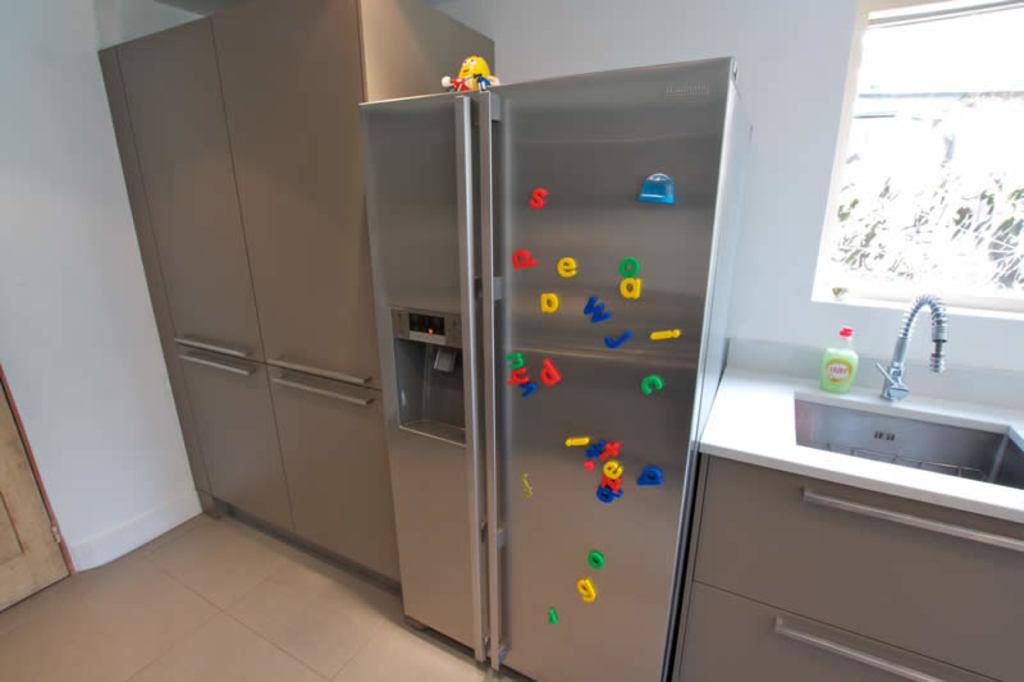What are the letters on the fridge?
Your response must be concise. Dfeoawjcdnyteoga. 